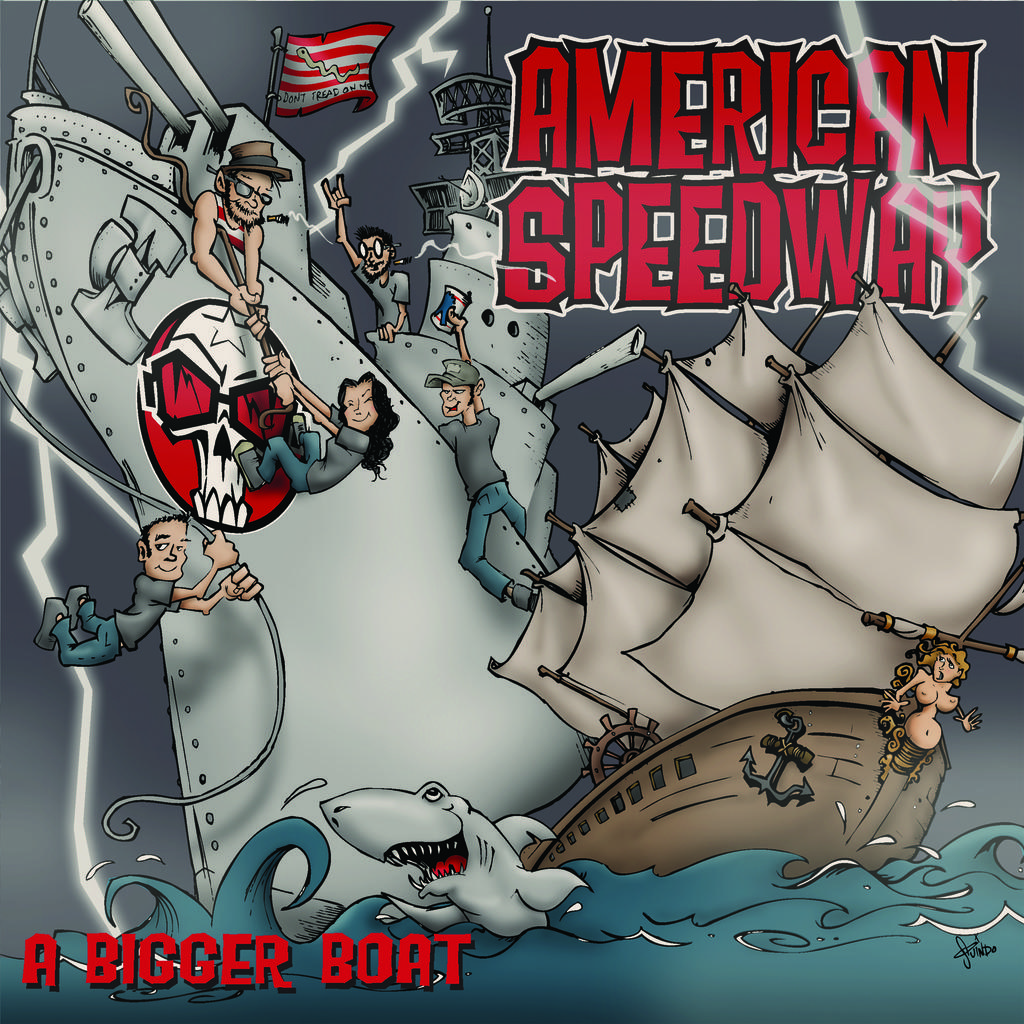What is the size of the boat?
Offer a very short reply. Bigger. What does it say on the top right?
Offer a very short reply. American speedway. 